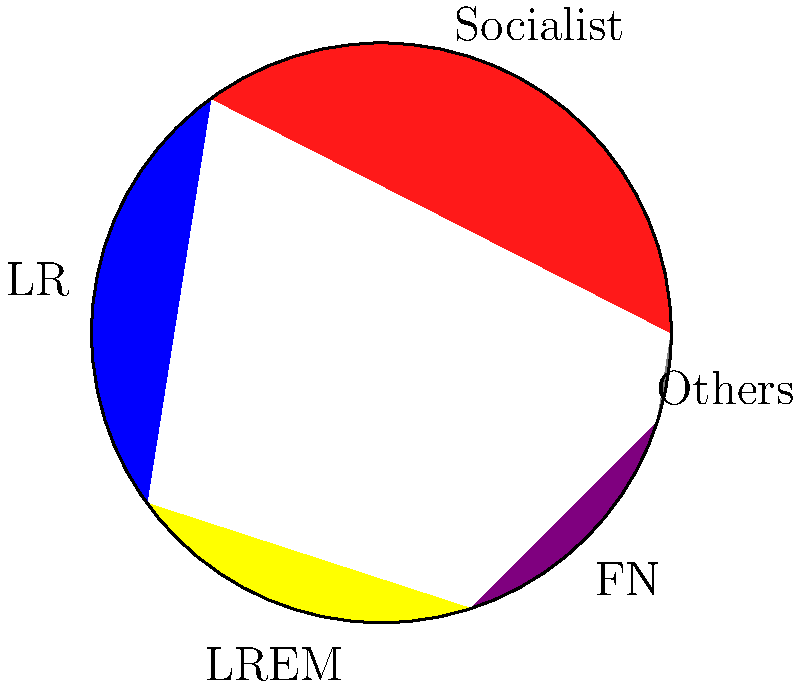Based on the pie chart showing the distribution of votes in Essonne's 3rd constituency, what percentage of votes did the Socialist party receive, and how does it compare to the combined votes of LR (Les Républicains) and LREM (La République En Marche)? To answer this question, we need to analyze the pie chart and perform some calculations:

1. Identify the Socialist party's share:
   The red slice represents the Socialist party, which accounts for 35% of the votes.

2. Identify LR and LREM shares:
   - LR (blue slice): 25% of votes
   - LREM (yellow slice): 20% of votes

3. Calculate the combined votes of LR and LREM:
   $25\% + 20\% = 45\%$

4. Compare Socialist votes to LR and LREM combined:
   Socialist: 35%
   LR + LREM: 45%

5. Calculate the difference:
   $45\% - 35\% = 10\%$

The Socialist party received 35% of the votes, which is 10 percentage points less than the combined votes of LR and LREM (45%).
Answer: 35%; 10 percentage points less than LR and LREM combined 